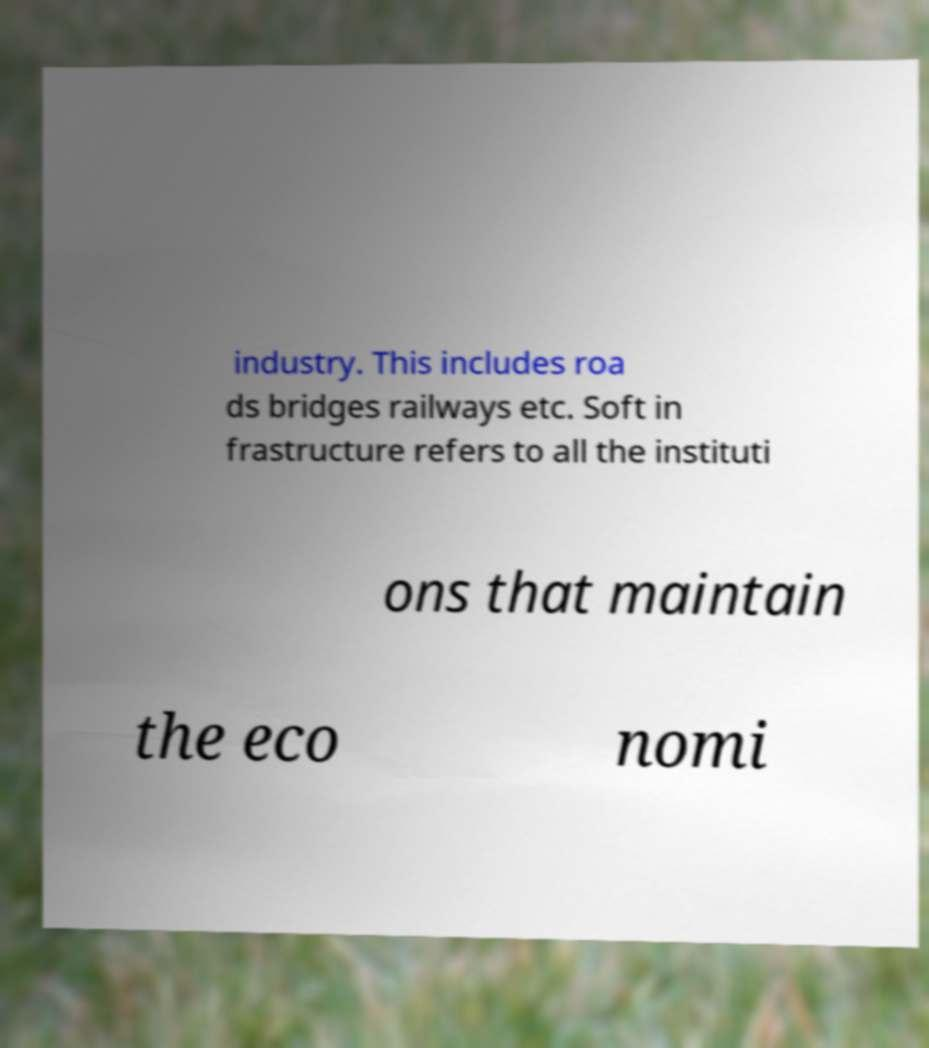Can you read and provide the text displayed in the image?This photo seems to have some interesting text. Can you extract and type it out for me? industry. This includes roa ds bridges railways etc. Soft in frastructure refers to all the instituti ons that maintain the eco nomi 